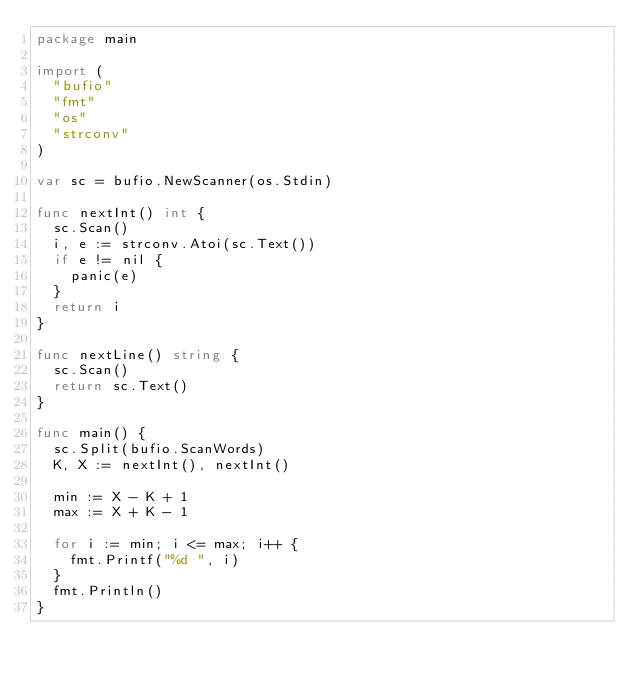<code> <loc_0><loc_0><loc_500><loc_500><_Go_>package main

import (
	"bufio"
	"fmt"
	"os"
	"strconv"
)

var sc = bufio.NewScanner(os.Stdin)

func nextInt() int {
	sc.Scan()
	i, e := strconv.Atoi(sc.Text())
	if e != nil {
		panic(e)
	}
	return i
}

func nextLine() string {
	sc.Scan()
	return sc.Text()
}

func main() {
	sc.Split(bufio.ScanWords)
	K, X := nextInt(), nextInt()

	min := X - K + 1
	max := X + K - 1

	for i := min; i <= max; i++ {
		fmt.Printf("%d ", i)
	}
	fmt.Println()
}
</code> 